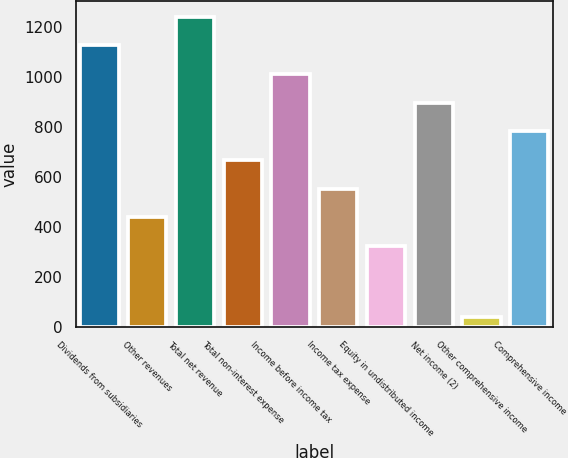Convert chart to OTSL. <chart><loc_0><loc_0><loc_500><loc_500><bar_chart><fcel>Dividends from subsidiaries<fcel>Other revenues<fcel>Total net revenue<fcel>Total non-interest expense<fcel>Income before income tax<fcel>Income tax expense<fcel>Equity in undistributed income<fcel>Net income (2)<fcel>Other comprehensive income<fcel>Comprehensive income<nl><fcel>1126.6<fcel>437.8<fcel>1241.4<fcel>667.4<fcel>1011.8<fcel>552.6<fcel>323<fcel>897<fcel>38<fcel>782.2<nl></chart> 